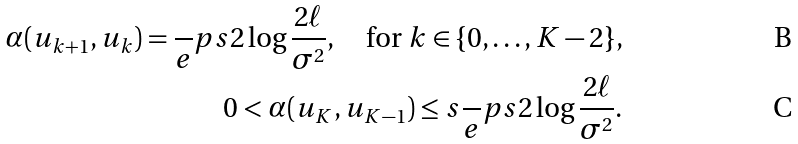<formula> <loc_0><loc_0><loc_500><loc_500>\alpha ( u _ { k + 1 } , u _ { k } ) = \frac { \ } { e } p s 2 \log \frac { 2 \ell } { \sigma ^ { 2 } } , \quad \text {for $k\in\{0,\dots,K-2\}$,} \\ 0 < \alpha ( u _ { K } , u _ { K - 1 } ) \leq s \frac { \ } { e } p s 2 \log \frac { 2 \ell } { \sigma ^ { 2 } } .</formula> 